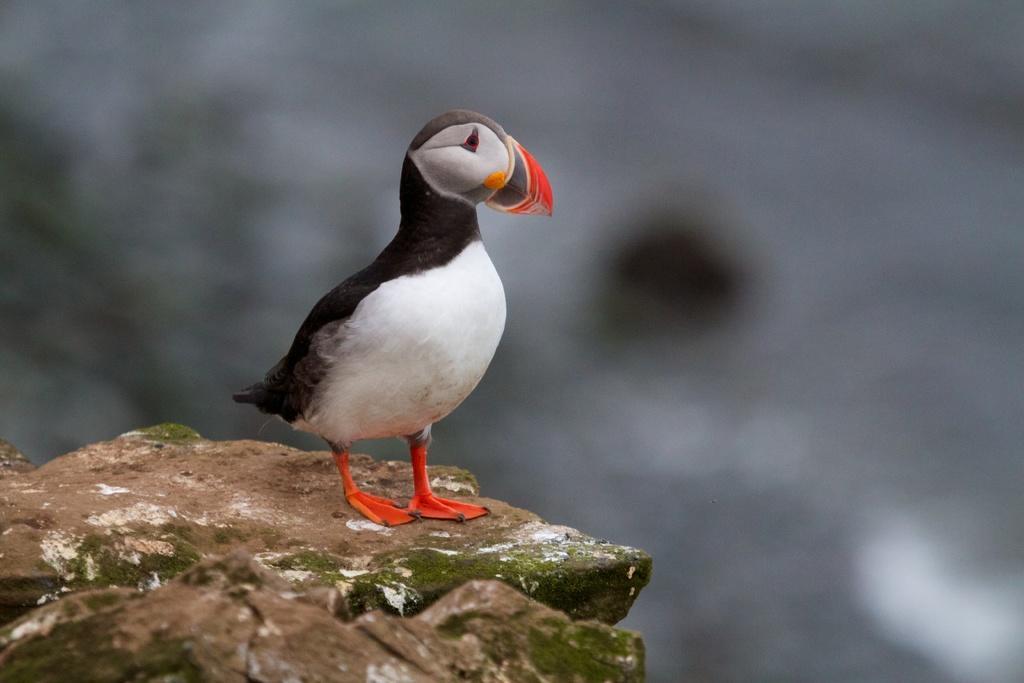Can you describe this image briefly? In this image there is a bird on the ground. The background is blurry. 